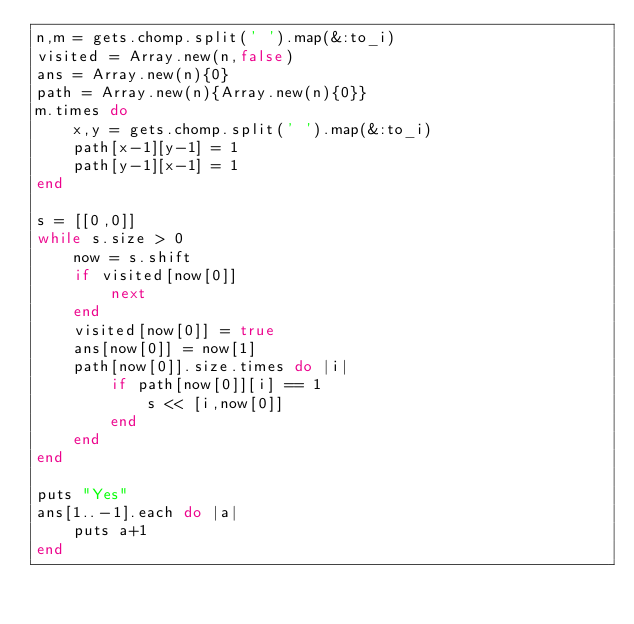Convert code to text. <code><loc_0><loc_0><loc_500><loc_500><_Ruby_>n,m = gets.chomp.split(' ').map(&:to_i)
visited = Array.new(n,false)
ans = Array.new(n){0}
path = Array.new(n){Array.new(n){0}}
m.times do
    x,y = gets.chomp.split(' ').map(&:to_i)
    path[x-1][y-1] = 1
    path[y-1][x-1] = 1
end

s = [[0,0]]
while s.size > 0
    now = s.shift
    if visited[now[0]]
        next
    end
    visited[now[0]] = true
    ans[now[0]] = now[1]
    path[now[0]].size.times do |i|
        if path[now[0]][i] == 1
            s << [i,now[0]]
        end
    end
end

puts "Yes"
ans[1..-1].each do |a|
    puts a+1
end</code> 